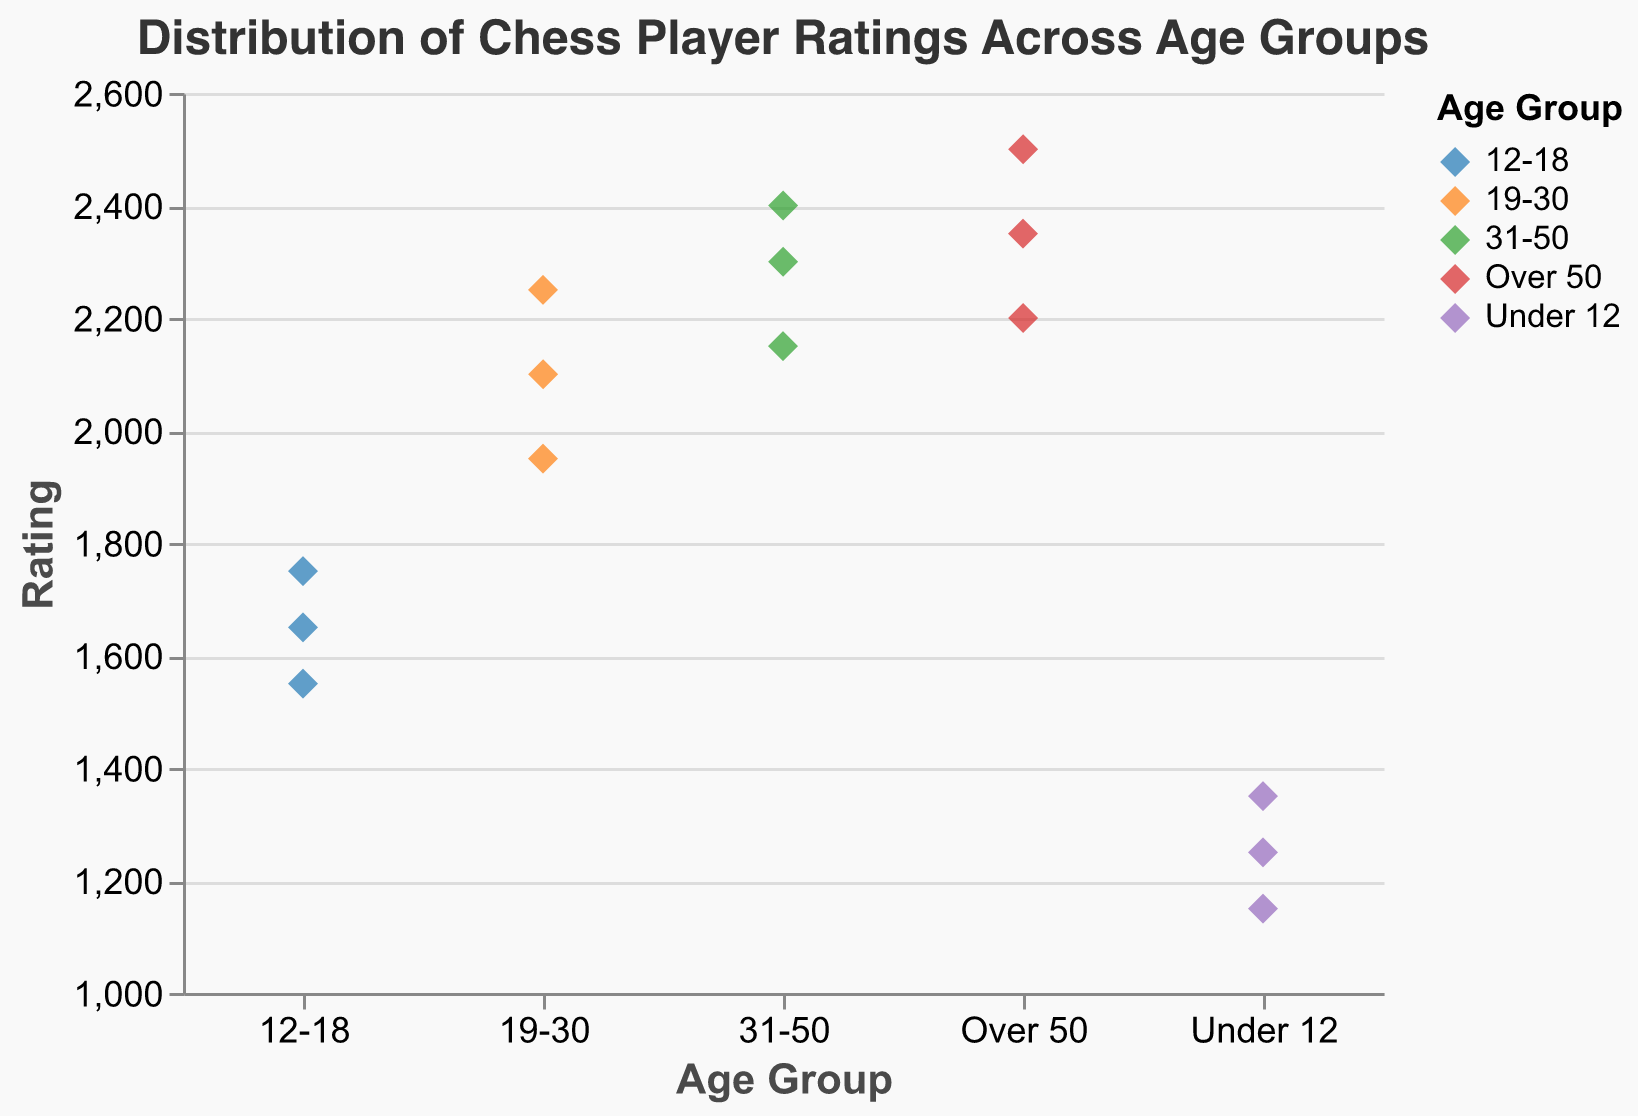Which age group has the highest rating? By observing the y-axis and the individual points on the plot, the highest rating of 2500 is associated with the "Over 50" age group.
Answer: Over 50 What's the range of ratings in the 31-50 age group? First, identify the lowest rating (2150) and the highest rating (2400) in the 31-50 age group. Calculate the range as the difference between the highest and lowest values: 2400 - 2150 = 250.
Answer: 250 Which age group has the most dispersed ratings? The dispersion can be visually estimated by the spread of points in each age group along the y-axis. The "Over 50" age group seems to be most dispersed, with ratings ranging from 2200 to 2500.
Answer: Over 50 How does the highest rating in the 12-18 age group compare to the lowest rating in the 19-30 age group? The highest rating in the 12-18 group is 1750. The lowest rating in the 19-30 group is 1950. Comparing these, 1750 is less than 1950.
Answer: Less than What is the median rating in the Under 12 age group? List the ratings in ascending order: 1150, 1250, 1350. The middle value (median) is 1250.
Answer: 1250 Are more experienced (over 50) players generally better than younger (under 12) players? Compare the range of ratings: Under 12 (1150-1350), Over 50 (2200-2500). The older age group has consistently higher ratings.
Answer: Yes What is the average rating for the 19-30 age group? Sum the ratings (2100 + 2250 + 1950 = 6300) and divide by the number of players (3): 6300 / 3 = 2100.
Answer: 2100 Which player has the highest rating, and what is their age group? The highest point on the y-axis is 2500, associated with "Viswanathan Anand" in the "Over 50" group.
Answer: Viswanathan Anand, Over 50 How many players are in the 12-18 age group? Count the number of points labeled "12-18": there are 3.
Answer: 3 